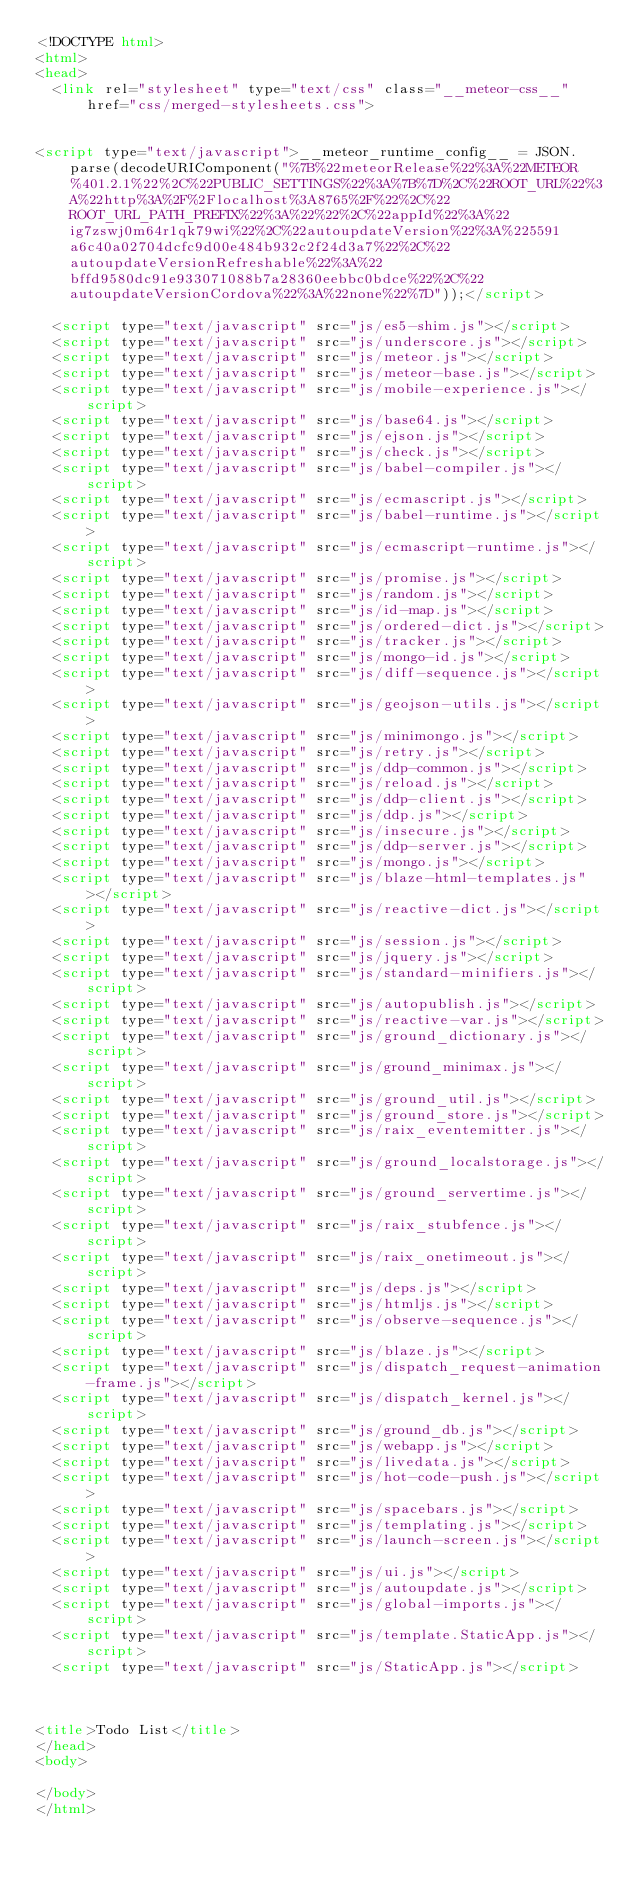<code> <loc_0><loc_0><loc_500><loc_500><_HTML_><!DOCTYPE html>
<html>
<head>
  <link rel="stylesheet" type="text/css" class="__meteor-css__" href="css/merged-stylesheets.css">


<script type="text/javascript">__meteor_runtime_config__ = JSON.parse(decodeURIComponent("%7B%22meteorRelease%22%3A%22METEOR%401.2.1%22%2C%22PUBLIC_SETTINGS%22%3A%7B%7D%2C%22ROOT_URL%22%3A%22http%3A%2F%2Flocalhost%3A8765%2F%22%2C%22ROOT_URL_PATH_PREFIX%22%3A%22%22%2C%22appId%22%3A%22ig7zswj0m64r1qk79wi%22%2C%22autoupdateVersion%22%3A%225591a6c40a02704dcfc9d00e484b932c2f24d3a7%22%2C%22autoupdateVersionRefreshable%22%3A%22bffd9580dc91e933071088b7a28360eebbc0bdce%22%2C%22autoupdateVersionCordova%22%3A%22none%22%7D"));</script>

  <script type="text/javascript" src="js/es5-shim.js"></script>
  <script type="text/javascript" src="js/underscore.js"></script>
  <script type="text/javascript" src="js/meteor.js"></script>
  <script type="text/javascript" src="js/meteor-base.js"></script>
  <script type="text/javascript" src="js/mobile-experience.js"></script>
  <script type="text/javascript" src="js/base64.js"></script>
  <script type="text/javascript" src="js/ejson.js"></script>
  <script type="text/javascript" src="js/check.js"></script>
  <script type="text/javascript" src="js/babel-compiler.js"></script>
  <script type="text/javascript" src="js/ecmascript.js"></script>
  <script type="text/javascript" src="js/babel-runtime.js"></script>
  <script type="text/javascript" src="js/ecmascript-runtime.js"></script>
  <script type="text/javascript" src="js/promise.js"></script>
  <script type="text/javascript" src="js/random.js"></script>
  <script type="text/javascript" src="js/id-map.js"></script>
  <script type="text/javascript" src="js/ordered-dict.js"></script>
  <script type="text/javascript" src="js/tracker.js"></script>
  <script type="text/javascript" src="js/mongo-id.js"></script>
  <script type="text/javascript" src="js/diff-sequence.js"></script>
  <script type="text/javascript" src="js/geojson-utils.js"></script>
  <script type="text/javascript" src="js/minimongo.js"></script>
  <script type="text/javascript" src="js/retry.js"></script>
  <script type="text/javascript" src="js/ddp-common.js"></script>
  <script type="text/javascript" src="js/reload.js"></script>
  <script type="text/javascript" src="js/ddp-client.js"></script>
  <script type="text/javascript" src="js/ddp.js"></script>
  <script type="text/javascript" src="js/insecure.js"></script>
  <script type="text/javascript" src="js/ddp-server.js"></script>
  <script type="text/javascript" src="js/mongo.js"></script>
  <script type="text/javascript" src="js/blaze-html-templates.js"></script>
  <script type="text/javascript" src="js/reactive-dict.js"></script>
  <script type="text/javascript" src="js/session.js"></script>
  <script type="text/javascript" src="js/jquery.js"></script>
  <script type="text/javascript" src="js/standard-minifiers.js"></script>
  <script type="text/javascript" src="js/autopublish.js"></script>
  <script type="text/javascript" src="js/reactive-var.js"></script>
  <script type="text/javascript" src="js/ground_dictionary.js"></script>
  <script type="text/javascript" src="js/ground_minimax.js"></script>
  <script type="text/javascript" src="js/ground_util.js"></script>
  <script type="text/javascript" src="js/ground_store.js"></script>
  <script type="text/javascript" src="js/raix_eventemitter.js"></script>
  <script type="text/javascript" src="js/ground_localstorage.js"></script>
  <script type="text/javascript" src="js/ground_servertime.js"></script>
  <script type="text/javascript" src="js/raix_stubfence.js"></script>
  <script type="text/javascript" src="js/raix_onetimeout.js"></script>
  <script type="text/javascript" src="js/deps.js"></script>
  <script type="text/javascript" src="js/htmljs.js"></script>
  <script type="text/javascript" src="js/observe-sequence.js"></script>
  <script type="text/javascript" src="js/blaze.js"></script>
  <script type="text/javascript" src="js/dispatch_request-animation-frame.js"></script>
  <script type="text/javascript" src="js/dispatch_kernel.js"></script>
  <script type="text/javascript" src="js/ground_db.js"></script>
  <script type="text/javascript" src="js/webapp.js"></script>
  <script type="text/javascript" src="js/livedata.js"></script>
  <script type="text/javascript" src="js/hot-code-push.js"></script>
  <script type="text/javascript" src="js/spacebars.js"></script>
  <script type="text/javascript" src="js/templating.js"></script>
  <script type="text/javascript" src="js/launch-screen.js"></script>
  <script type="text/javascript" src="js/ui.js"></script>
  <script type="text/javascript" src="js/autoupdate.js"></script>
  <script type="text/javascript" src="js/global-imports.js"></script>
  <script type="text/javascript" src="js/template.StaticApp.js"></script>
  <script type="text/javascript" src="js/StaticApp.js"></script>



<title>Todo List</title>
</head>
<body>

</body>
</html>
</code> 